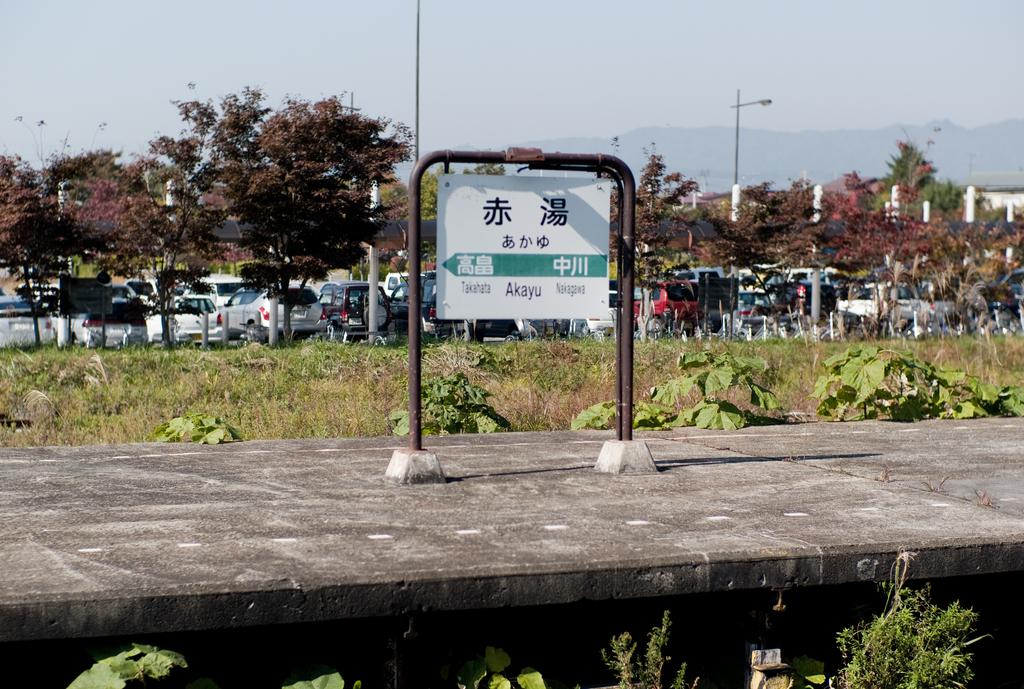What type of vehicles can be seen parked on the floor in the image? There are motor vehicles parked on the floor in the image. What can be found in the image to provide information or directions? There is an information board in the image. What type of natural environment is visible in the image? Grass, bushes, trees, and hills are visible in the image. What architectural features can be seen in the image? Street poles and street lights are in the image. What part of the natural environment is visible in the image? The sky is visible in the image. What type of country music rhythm can be heard in the image? There is no music or sound present in the image, so it is not possible to determine the rhythm or type of music. 